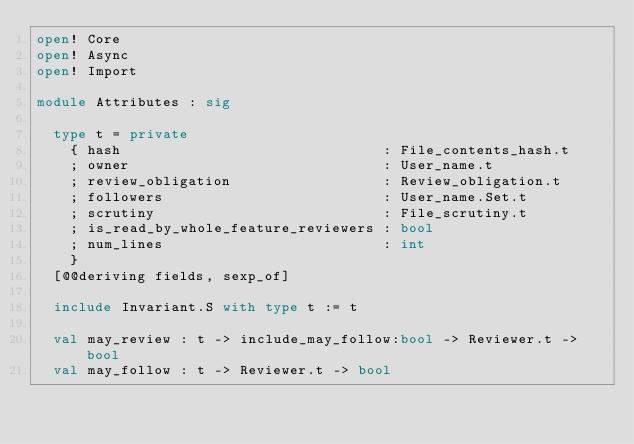Convert code to text. <code><loc_0><loc_0><loc_500><loc_500><_OCaml_>open! Core
open! Async
open! Import

module Attributes : sig

  type t = private
    { hash                               : File_contents_hash.t
    ; owner                              : User_name.t
    ; review_obligation                  : Review_obligation.t
    ; followers                          : User_name.Set.t
    ; scrutiny                           : File_scrutiny.t
    ; is_read_by_whole_feature_reviewers : bool
    ; num_lines                          : int
    }
  [@@deriving fields, sexp_of]

  include Invariant.S with type t := t

  val may_review : t -> include_may_follow:bool -> Reviewer.t -> bool
  val may_follow : t -> Reviewer.t -> bool
</code> 